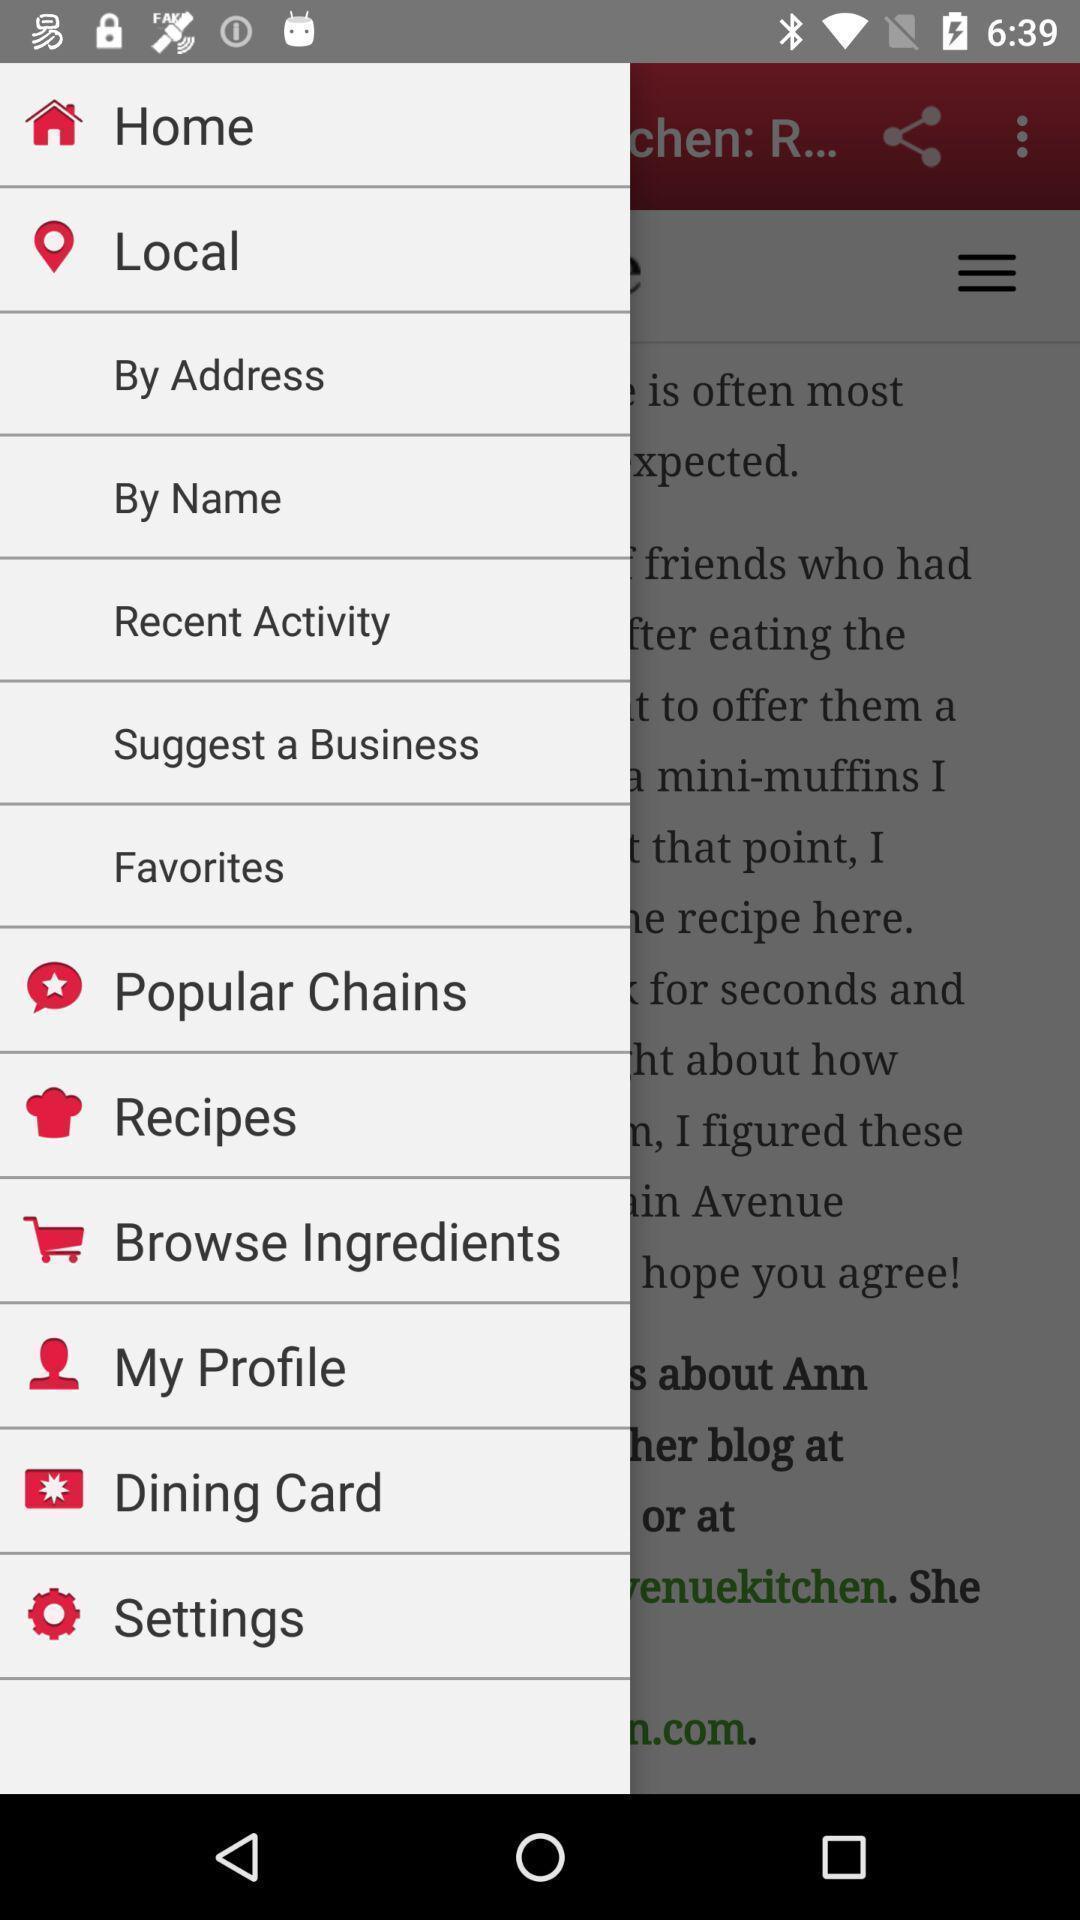Provide a textual representation of this image. Social app showing list of home options. 